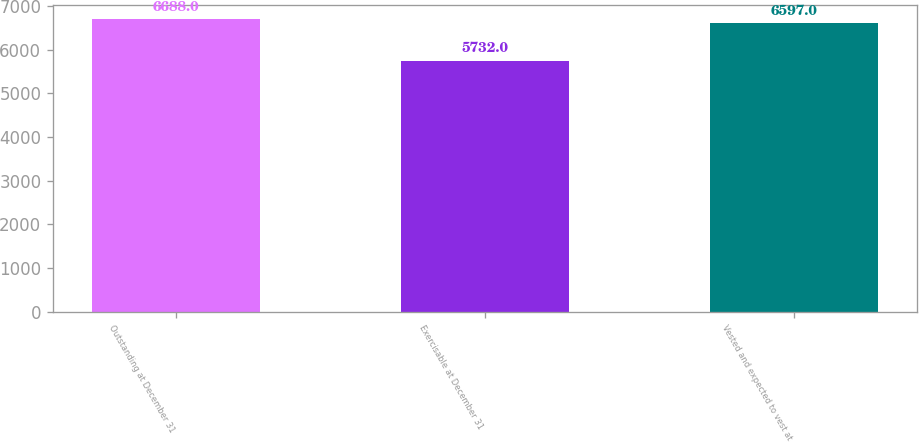<chart> <loc_0><loc_0><loc_500><loc_500><bar_chart><fcel>Outstanding at December 31<fcel>Exercisable at December 31<fcel>Vested and expected to vest at<nl><fcel>6688<fcel>5732<fcel>6597<nl></chart> 